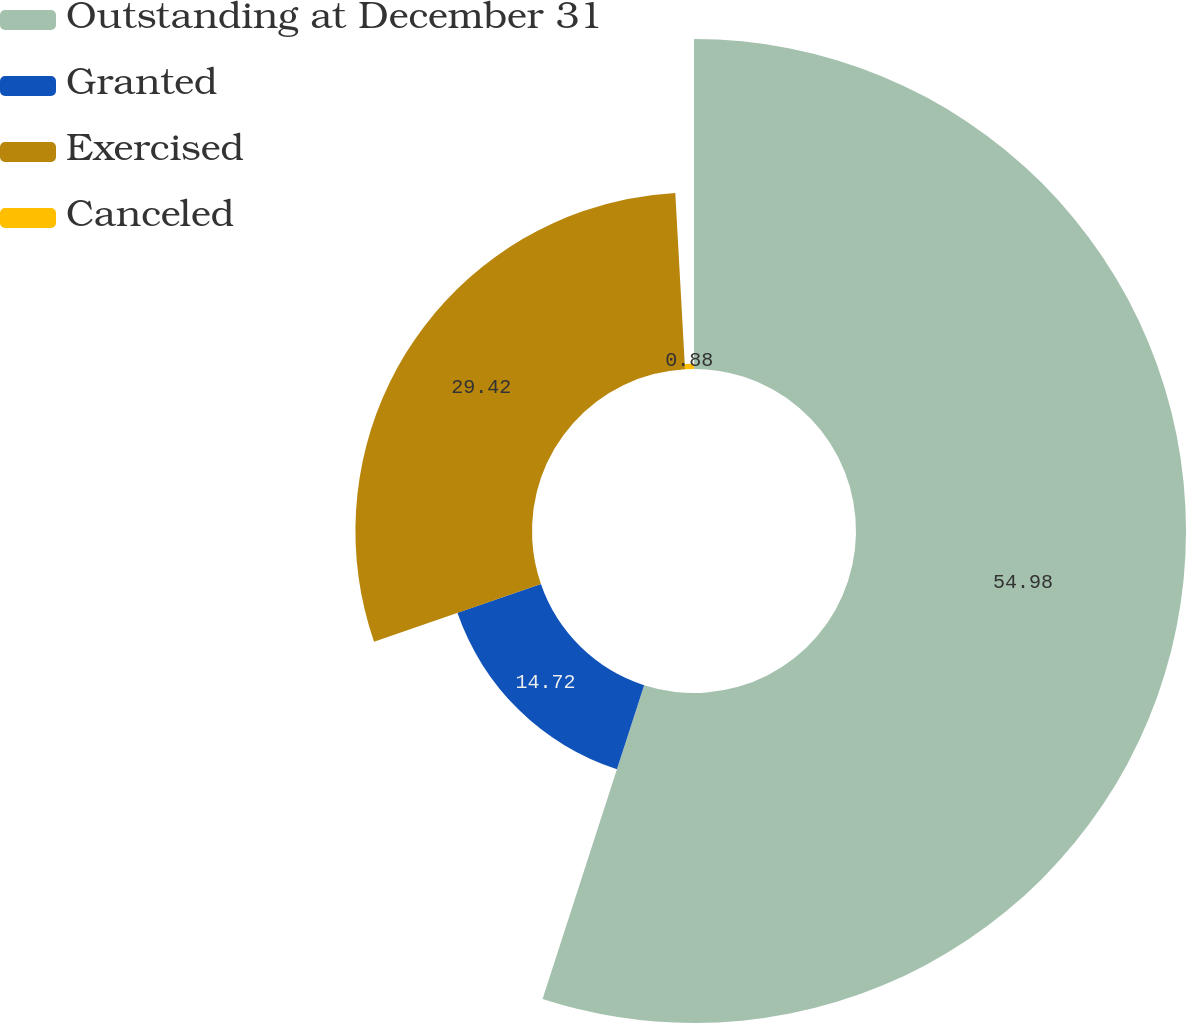Convert chart to OTSL. <chart><loc_0><loc_0><loc_500><loc_500><pie_chart><fcel>Outstanding at December 31<fcel>Granted<fcel>Exercised<fcel>Canceled<nl><fcel>54.98%<fcel>14.72%<fcel>29.42%<fcel>0.88%<nl></chart> 